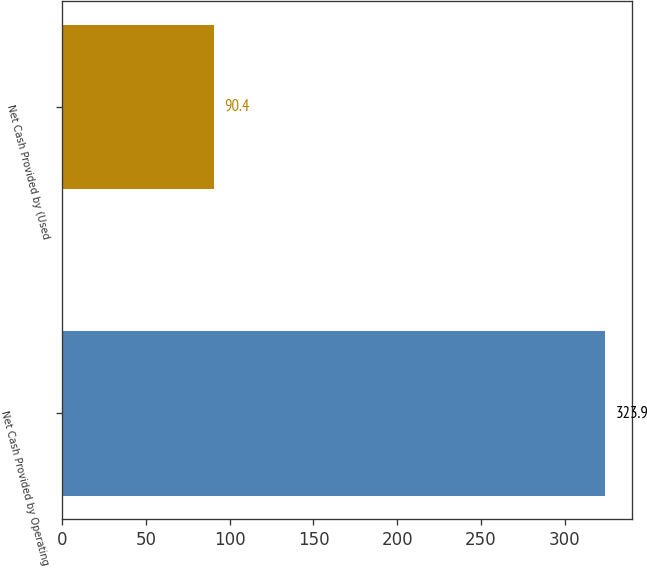<chart> <loc_0><loc_0><loc_500><loc_500><bar_chart><fcel>Net Cash Provided by Operating<fcel>Net Cash Provided by (Used<nl><fcel>323.9<fcel>90.4<nl></chart> 